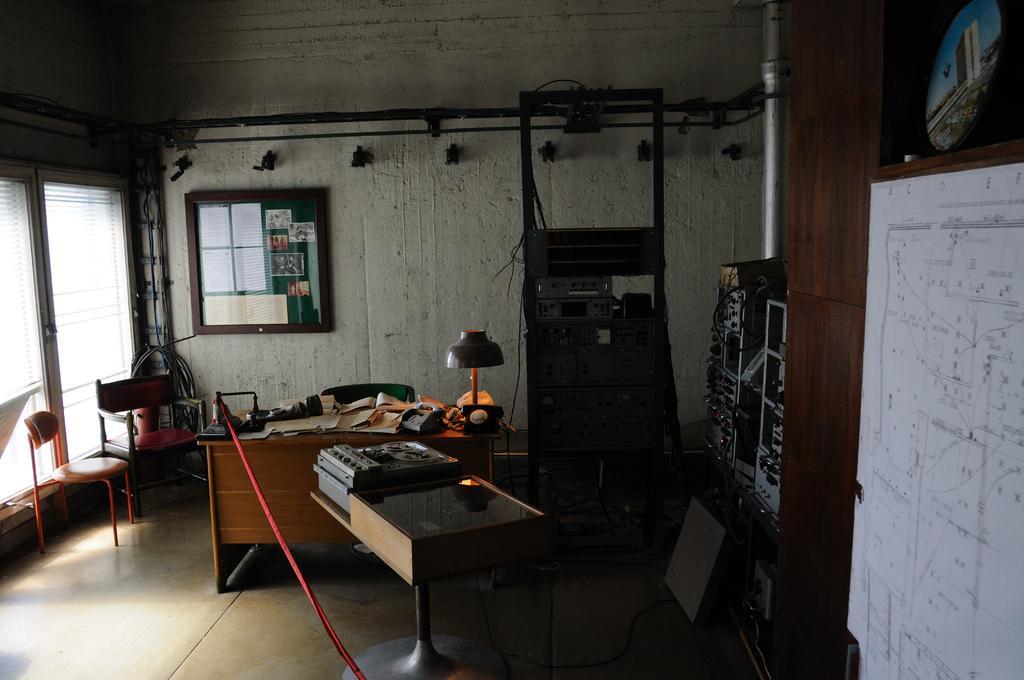In one or two sentences, can you explain what this image depicts? We can see papers,lamp and some objects on tables and we can see chairs. Right side of the image we can see electrical devices and paper on board. Background we can see board with papers and photos on a wall. Here we can see window. 